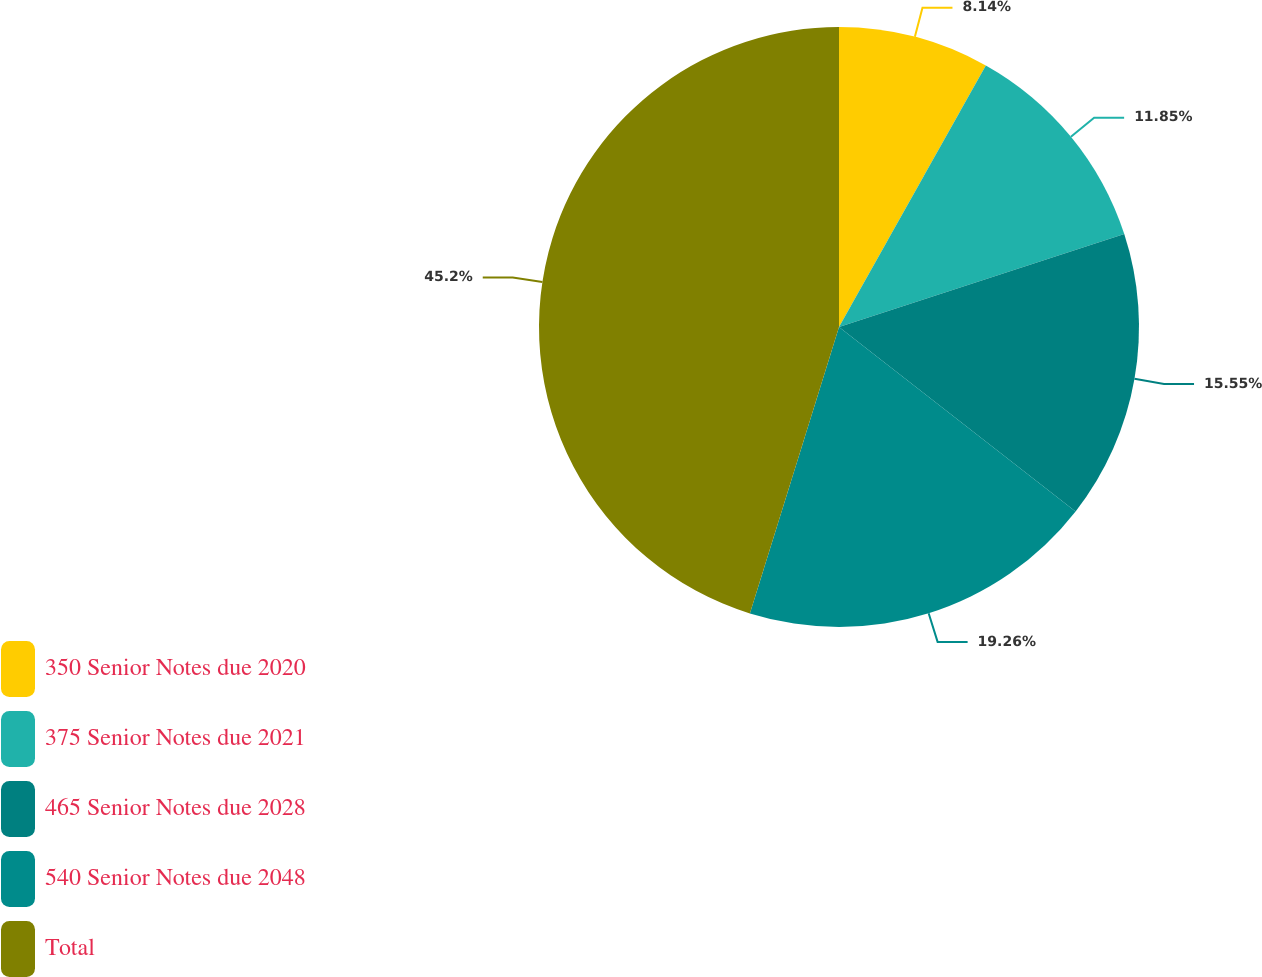Convert chart to OTSL. <chart><loc_0><loc_0><loc_500><loc_500><pie_chart><fcel>350 Senior Notes due 2020<fcel>375 Senior Notes due 2021<fcel>465 Senior Notes due 2028<fcel>540 Senior Notes due 2048<fcel>Total<nl><fcel>8.14%<fcel>11.85%<fcel>15.55%<fcel>19.26%<fcel>45.2%<nl></chart> 